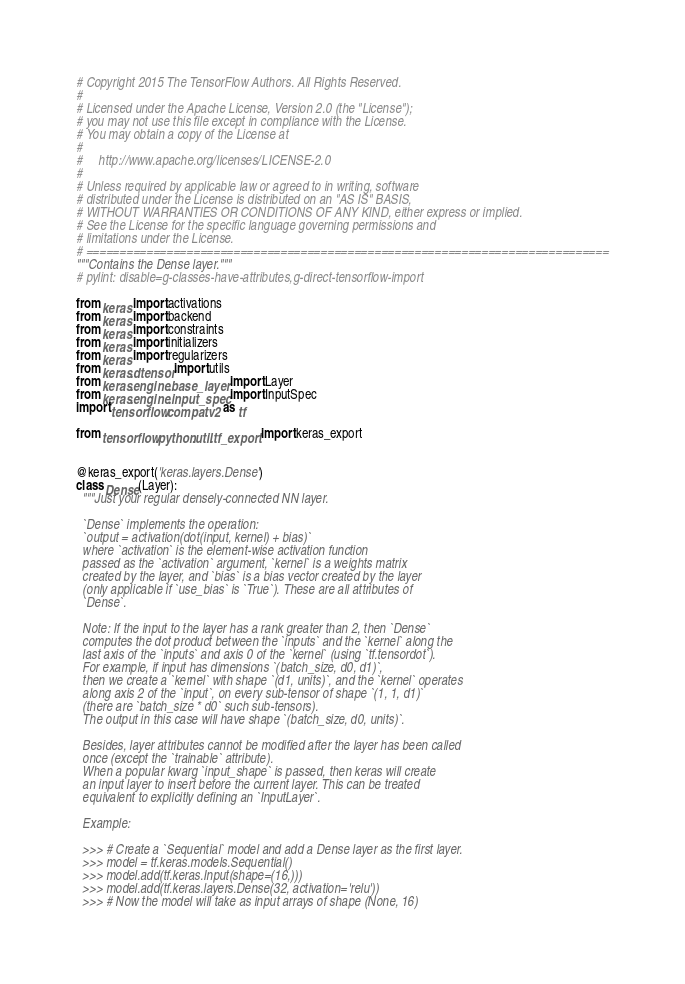Convert code to text. <code><loc_0><loc_0><loc_500><loc_500><_Python_># Copyright 2015 The TensorFlow Authors. All Rights Reserved.
#
# Licensed under the Apache License, Version 2.0 (the "License");
# you may not use this file except in compliance with the License.
# You may obtain a copy of the License at
#
#     http://www.apache.org/licenses/LICENSE-2.0
#
# Unless required by applicable law or agreed to in writing, software
# distributed under the License is distributed on an "AS IS" BASIS,
# WITHOUT WARRANTIES OR CONDITIONS OF ANY KIND, either express or implied.
# See the License for the specific language governing permissions and
# limitations under the License.
# ==============================================================================
"""Contains the Dense layer."""
# pylint: disable=g-classes-have-attributes,g-direct-tensorflow-import

from keras import activations
from keras import backend
from keras import constraints
from keras import initializers
from keras import regularizers
from keras.dtensor import utils
from keras.engine.base_layer import Layer
from keras.engine.input_spec import InputSpec
import tensorflow.compat.v2 as tf

from tensorflow.python.util.tf_export import keras_export


@keras_export('keras.layers.Dense')
class Dense(Layer):
  """Just your regular densely-connected NN layer.

  `Dense` implements the operation:
  `output = activation(dot(input, kernel) + bias)`
  where `activation` is the element-wise activation function
  passed as the `activation` argument, `kernel` is a weights matrix
  created by the layer, and `bias` is a bias vector created by the layer
  (only applicable if `use_bias` is `True`). These are all attributes of
  `Dense`.

  Note: If the input to the layer has a rank greater than 2, then `Dense`
  computes the dot product between the `inputs` and the `kernel` along the
  last axis of the `inputs` and axis 0 of the `kernel` (using `tf.tensordot`).
  For example, if input has dimensions `(batch_size, d0, d1)`,
  then we create a `kernel` with shape `(d1, units)`, and the `kernel` operates
  along axis 2 of the `input`, on every sub-tensor of shape `(1, 1, d1)`
  (there are `batch_size * d0` such sub-tensors).
  The output in this case will have shape `(batch_size, d0, units)`.

  Besides, layer attributes cannot be modified after the layer has been called
  once (except the `trainable` attribute).
  When a popular kwarg `input_shape` is passed, then keras will create
  an input layer to insert before the current layer. This can be treated
  equivalent to explicitly defining an `InputLayer`.

  Example:

  >>> # Create a `Sequential` model and add a Dense layer as the first layer.
  >>> model = tf.keras.models.Sequential()
  >>> model.add(tf.keras.Input(shape=(16,)))
  >>> model.add(tf.keras.layers.Dense(32, activation='relu'))
  >>> # Now the model will take as input arrays of shape (None, 16)</code> 